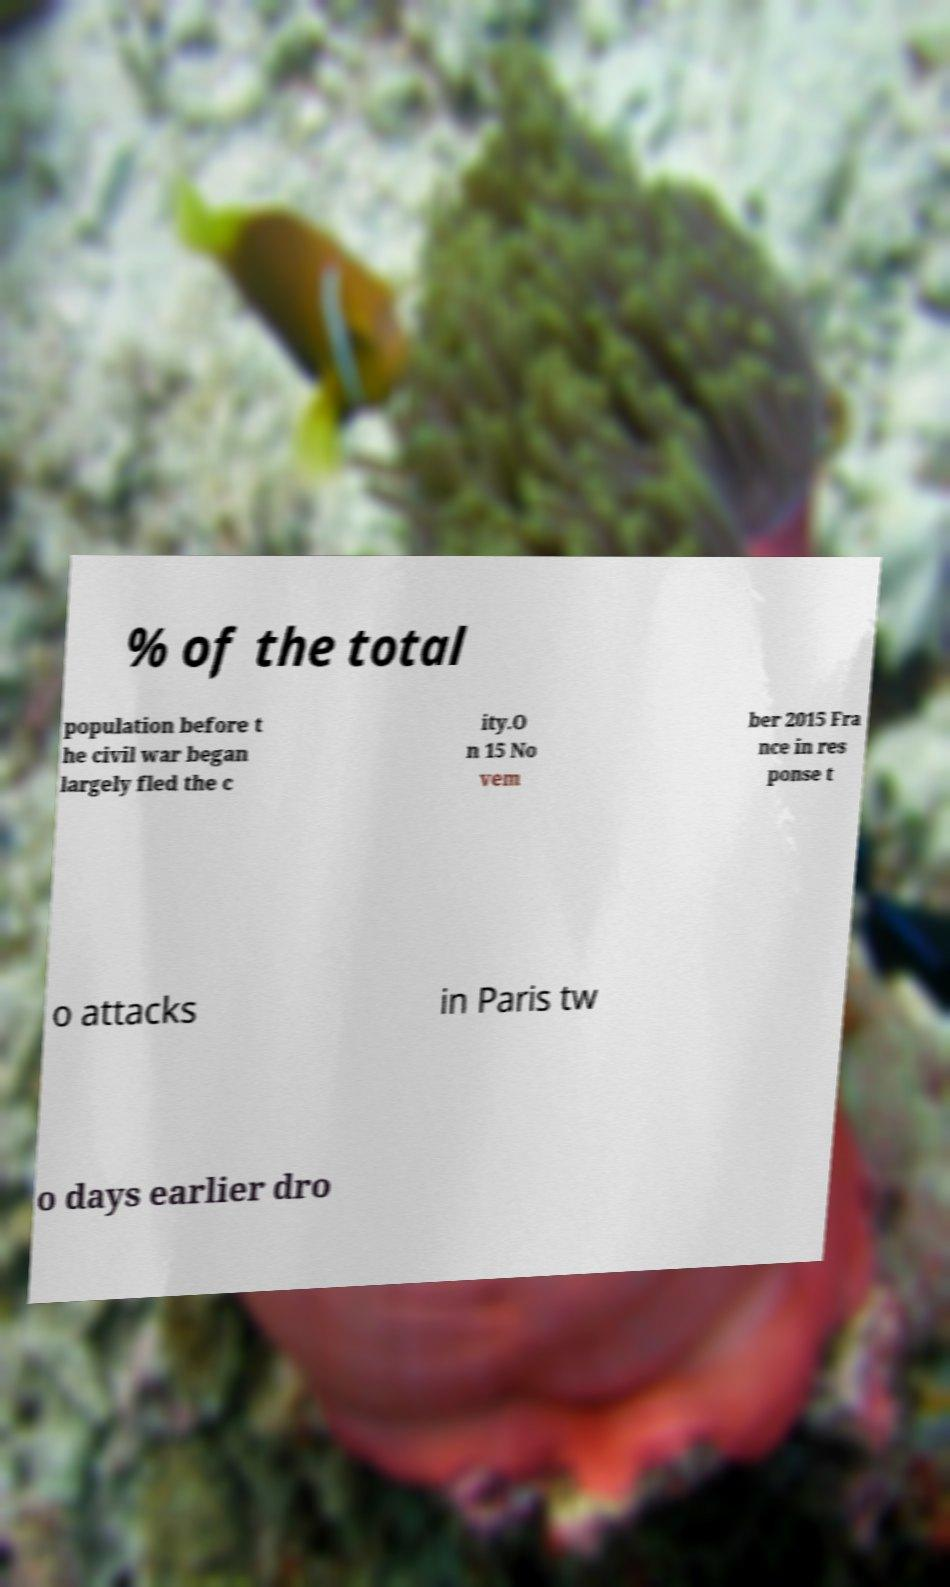What messages or text are displayed in this image? I need them in a readable, typed format. % of the total population before t he civil war began largely fled the c ity.O n 15 No vem ber 2015 Fra nce in res ponse t o attacks in Paris tw o days earlier dro 